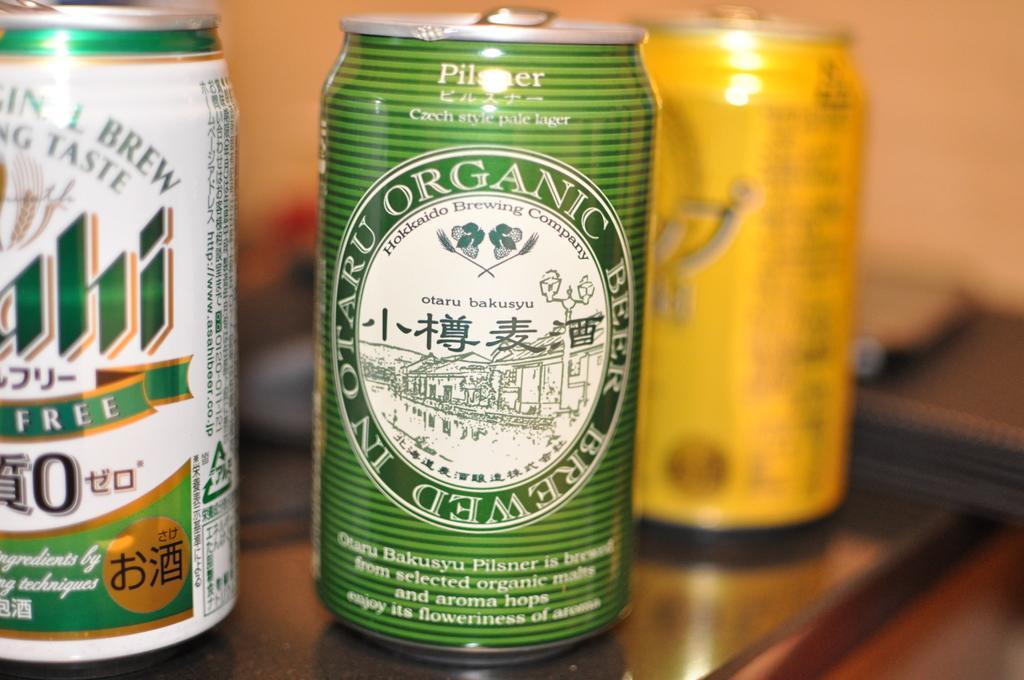Could you give a brief overview of what you see in this image? In this picture we can see three tins on a platform. There is a blur background. 